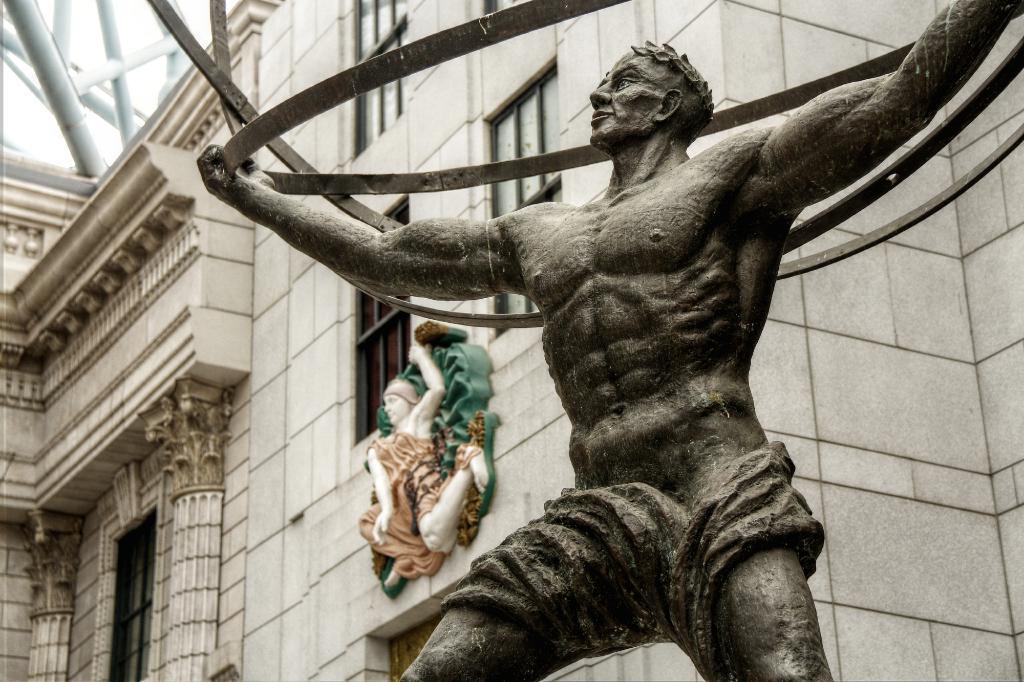Could you give a brief overview of what you see in this image? This image is taken outdoors. In the middle of the image there is a sculpture of a man. In the background there is a building with walls, windows, a door, carvings, architecture and a roof. There are few iron bars. 